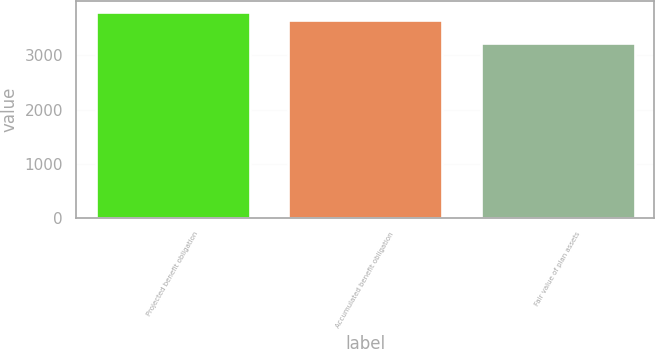Convert chart. <chart><loc_0><loc_0><loc_500><loc_500><bar_chart><fcel>Projected benefit obligation<fcel>Accumulated benefit obligation<fcel>Fair value of plan assets<nl><fcel>3805.8<fcel>3658.3<fcel>3232.1<nl></chart> 